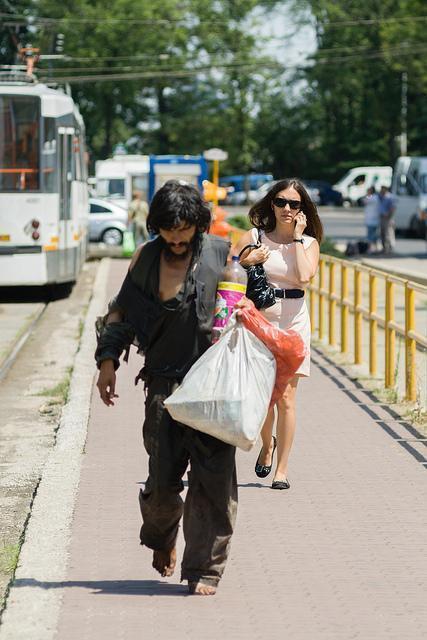How many people in this scene aren't wearing shoes?
Give a very brief answer. 1. How many people can be seen?
Give a very brief answer. 2. How many bear arms are raised to the bears' ears?
Give a very brief answer. 0. 